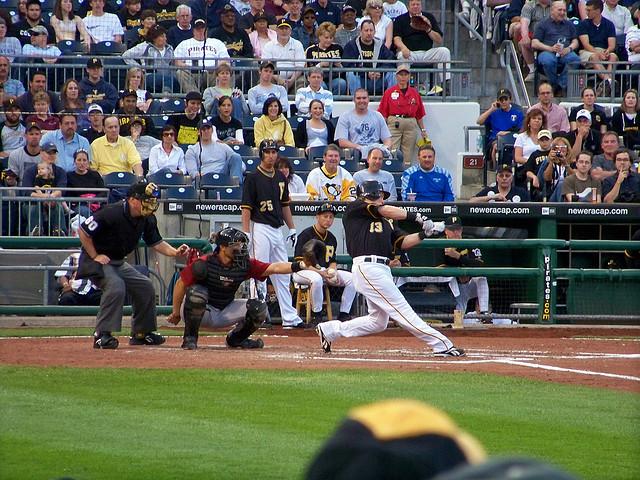What kind of sport is being played here?
Quick response, please. Baseball. What is the number on the batter's shirt?
Short answer required. 13. Is the batter right-handed?
Be succinct. Yes. 